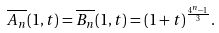Convert formula to latex. <formula><loc_0><loc_0><loc_500><loc_500>\overline { A _ { n } } ( 1 , t ) = \overline { B _ { n } } ( 1 , t ) = ( 1 + t ) ^ { \frac { 4 ^ { n } - 1 } { 3 } } .</formula> 